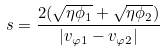<formula> <loc_0><loc_0><loc_500><loc_500>s = \frac { 2 ( \sqrt { \eta \phi _ { 1 } } + \sqrt { \eta \phi _ { 2 } } ) } { | v _ { \varphi 1 } - v _ { \varphi 2 } | }</formula> 